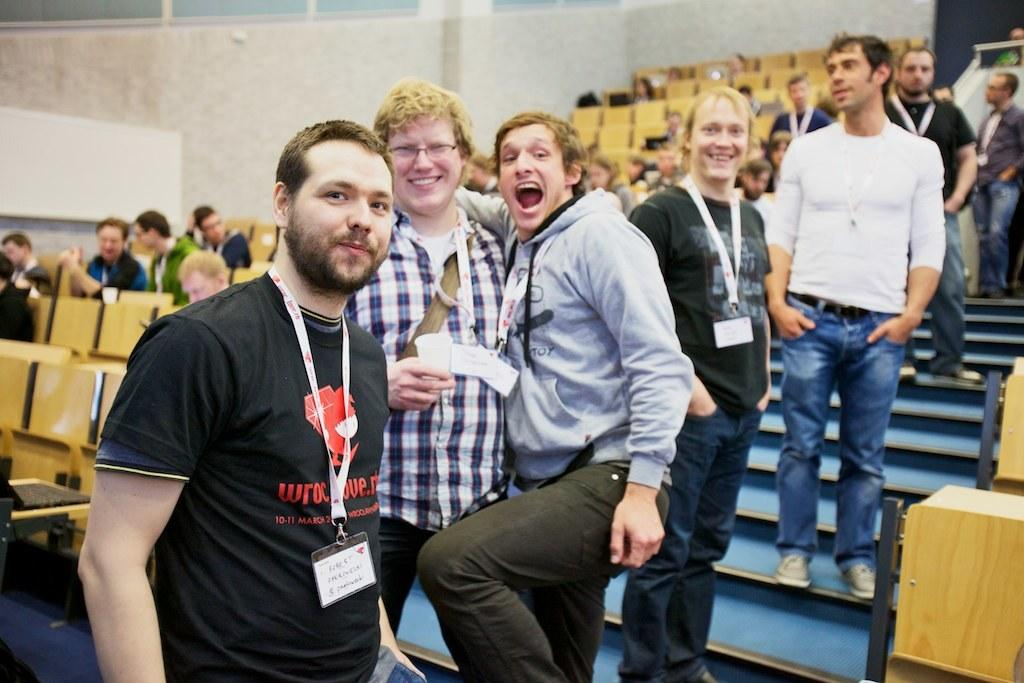What type of space is shown in the image? The image depicts a room. What furniture can be seen in the room? There are multiple chairs in the room. What are the people in the image doing? Some people are sitting on the chairs, and there are people standing on steps between the chairs. Reasoning: Let' Let's think step by step in order to produce the conversation. We start by identifying the main space shown in the image, which is a room. Then, we describe the furniture present in the room, which are chairs. Finally, we observe the actions of the people in the image, noting that some are sitting on chairs while others are standing on steps between the chairs. Absurd Question/Answer: Can you tell me how many docks are visible in the image? There are no docks present in the image; it depicts a room with chairs and people. What type of print is visible on the chairs in the image? There is no specific print mentioned on the chairs in the image; only the presence of chairs is noted. 